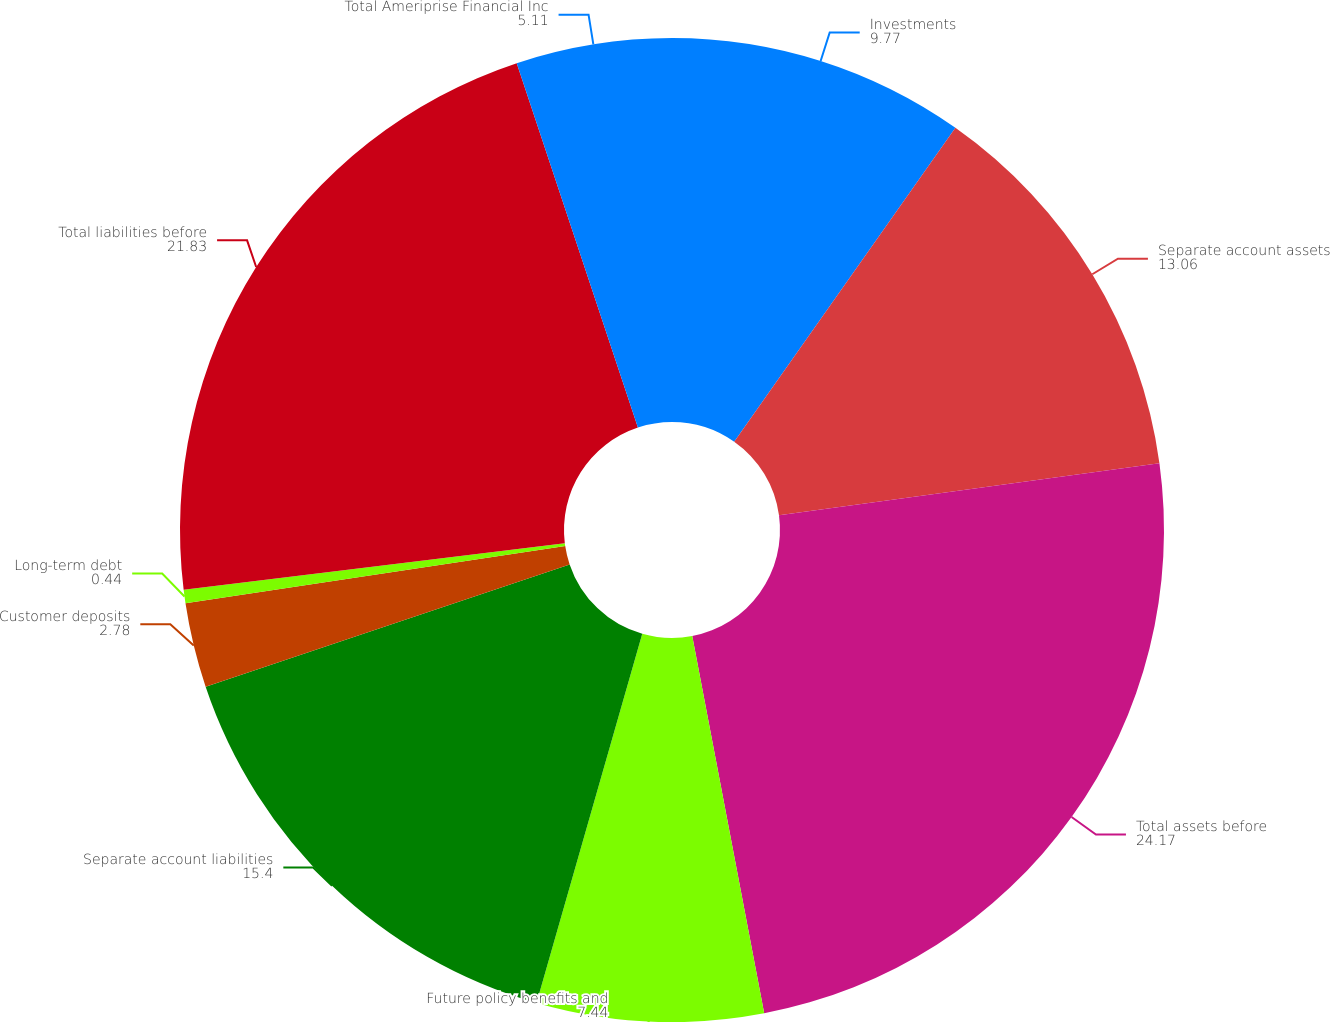<chart> <loc_0><loc_0><loc_500><loc_500><pie_chart><fcel>Investments<fcel>Separate account assets<fcel>Total assets before<fcel>Future policy benefits and<fcel>Separate account liabilities<fcel>Customer deposits<fcel>Long-term debt<fcel>Total liabilities before<fcel>Total Ameriprise Financial Inc<nl><fcel>9.77%<fcel>13.06%<fcel>24.17%<fcel>7.44%<fcel>15.4%<fcel>2.78%<fcel>0.44%<fcel>21.83%<fcel>5.11%<nl></chart> 